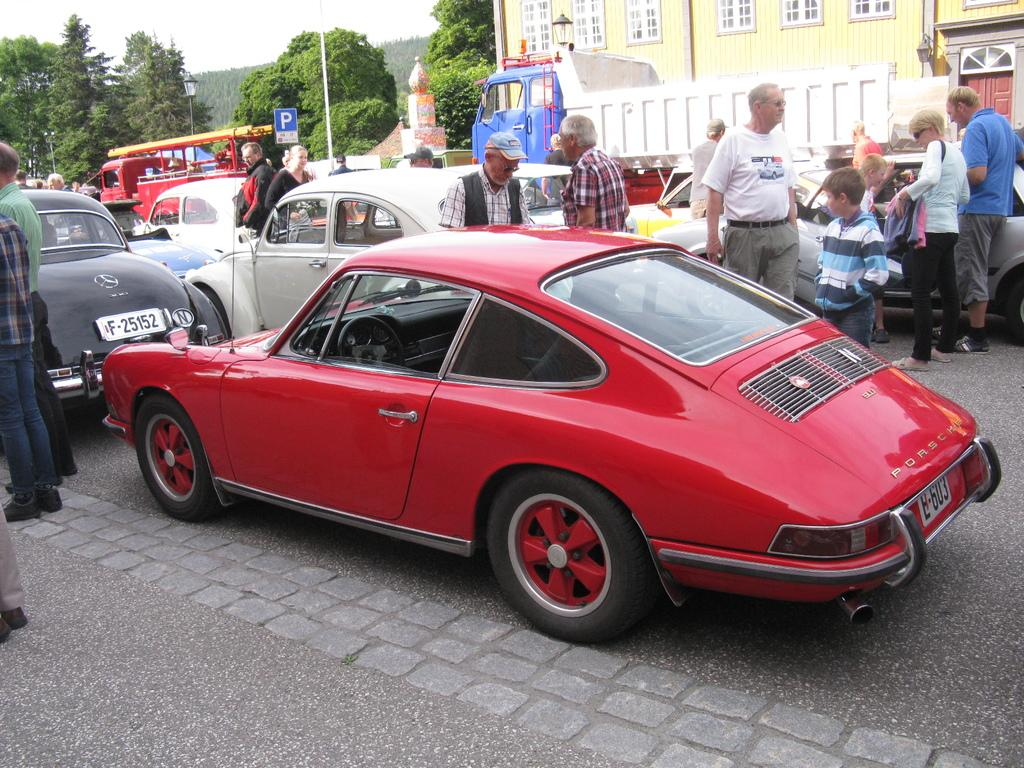What can be seen in the image? There are vehicles and people standing on the road in the image. What is visible in the background of the image? There is a building, trees, the sky, poles, and other objects in the background of the image. How many types of objects can be seen in the background? There are at least five types of objects visible in the background: a building, trees, the sky, poles, and other objects. Can you tell me how many boys are sailing in the image? There are no boys or sailing activities present in the image. What type of cover is protecting the vehicles from the sun in the image? There is no cover visible in the image; the vehicles are exposed to the sky. 